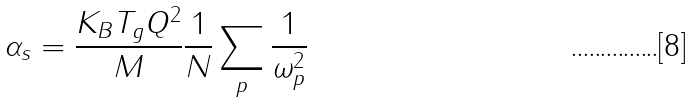<formula> <loc_0><loc_0><loc_500><loc_500>\alpha _ { s } = \frac { K _ { B } T _ { g } Q ^ { 2 } } { M } \frac { 1 } { N } \sum _ { p } { \frac { 1 } { \omega ^ { 2 } _ { p } } }</formula> 